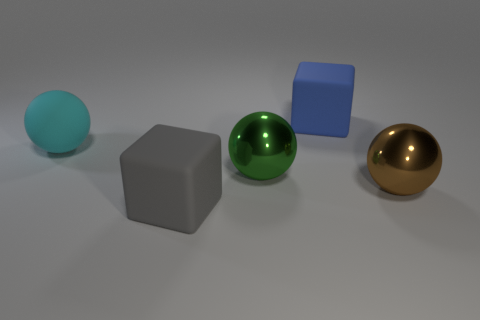Are there fewer large gray cubes that are behind the cyan ball than green metal balls?
Ensure brevity in your answer.  Yes. Is the material of the large brown thing the same as the large green thing that is behind the big gray block?
Give a very brief answer. Yes. There is a big sphere that is on the left side of the large matte thing that is in front of the big cyan thing; are there any brown metal objects right of it?
Provide a succinct answer. Yes. There is a big ball that is the same material as the big gray cube; what is its color?
Your response must be concise. Cyan. Are there fewer cyan rubber things that are in front of the big gray thing than big gray rubber objects behind the green metallic sphere?
Your response must be concise. No. Are the large cube that is in front of the large blue cube and the big cube that is behind the big brown sphere made of the same material?
Ensure brevity in your answer.  Yes. There is a big rubber thing that is behind the brown metallic sphere and in front of the big blue thing; what shape is it?
Provide a succinct answer. Sphere. What material is the big thing behind the rubber thing that is left of the gray rubber block?
Provide a short and direct response. Rubber. Is the number of gray rubber blocks greater than the number of rubber objects?
Keep it short and to the point. No. There is a gray block that is the same size as the brown shiny sphere; what is its material?
Offer a very short reply. Rubber. 